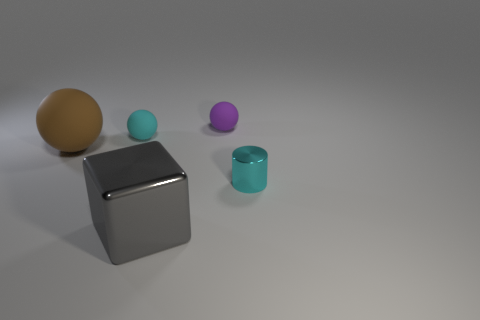There is a matte sphere that is the same color as the tiny metallic cylinder; what size is it?
Ensure brevity in your answer.  Small. What number of tiny spheres are the same color as the metal cylinder?
Your answer should be compact. 1. Is there a purple rubber object that has the same shape as the big brown matte thing?
Give a very brief answer. Yes. Are there an equal number of rubber balls that are to the left of the large gray thing and small cyan matte balls to the right of the big brown ball?
Offer a terse response. No. There is a thing that is to the right of the tiny purple rubber sphere; does it have the same shape as the brown matte object?
Your answer should be very brief. No. Is the large gray thing the same shape as the cyan metal object?
Your answer should be very brief. No. How many metal things are either tiny balls or large gray cubes?
Make the answer very short. 1. What material is the small thing that is the same color as the cylinder?
Make the answer very short. Rubber. Is the purple thing the same size as the cyan rubber ball?
Your response must be concise. Yes. How many objects are either gray balls or objects that are behind the small cylinder?
Keep it short and to the point. 3. 